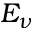Convert formula to latex. <formula><loc_0><loc_0><loc_500><loc_500>E _ { \nu }</formula> 